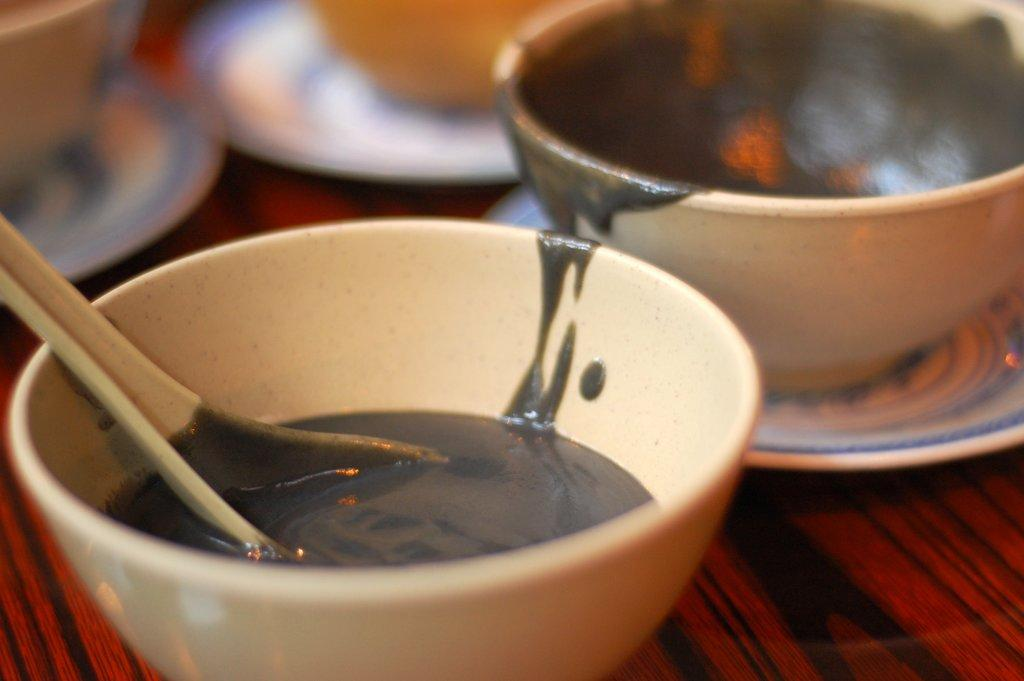How many cups are visible in the image? There are two cups in the image. Where are the cups located? The cups are on a table. What type of haircut is the baby getting in the image? There is no baby or haircut present in the image; it only features two cups on a table. 